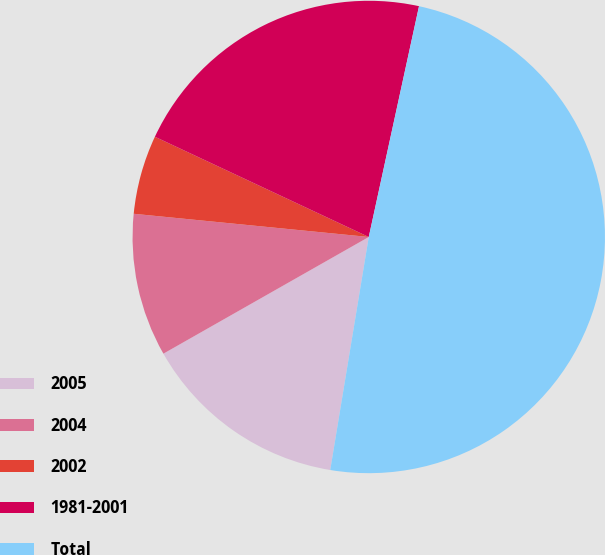Convert chart. <chart><loc_0><loc_0><loc_500><loc_500><pie_chart><fcel>2005<fcel>2004<fcel>2002<fcel>1981-2001<fcel>Total<nl><fcel>14.17%<fcel>9.79%<fcel>5.41%<fcel>21.44%<fcel>49.2%<nl></chart> 